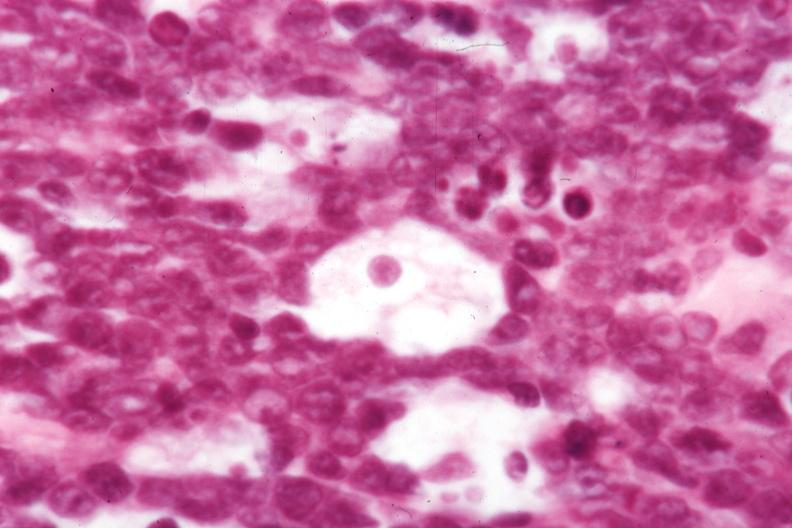s morphology typical for dx?
Answer the question using a single word or phrase. Yes 